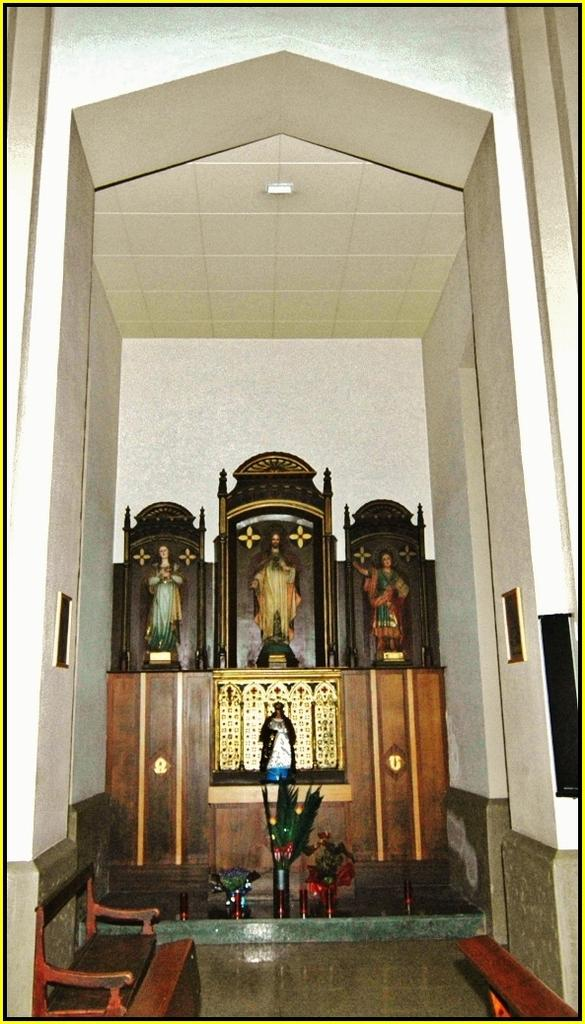What type of furniture can be seen in the image? There are tables in the image. What religious figures are present in the image? There are Jesus statues in the image. What structure is visible above the tables and statues? There is a roof in the image. What surrounds the scene in the image? There are walls on both sides of the image. What decorative items can be found at the bottom of the image? There are showpieces at the bottom of the image. How many giants are present in the image? There are no giants present in the image. What shape is the showpiece at the bottom of the image? The provided facts do not mention the shape of the showpieces, so we cannot determine their shape from the information given. 